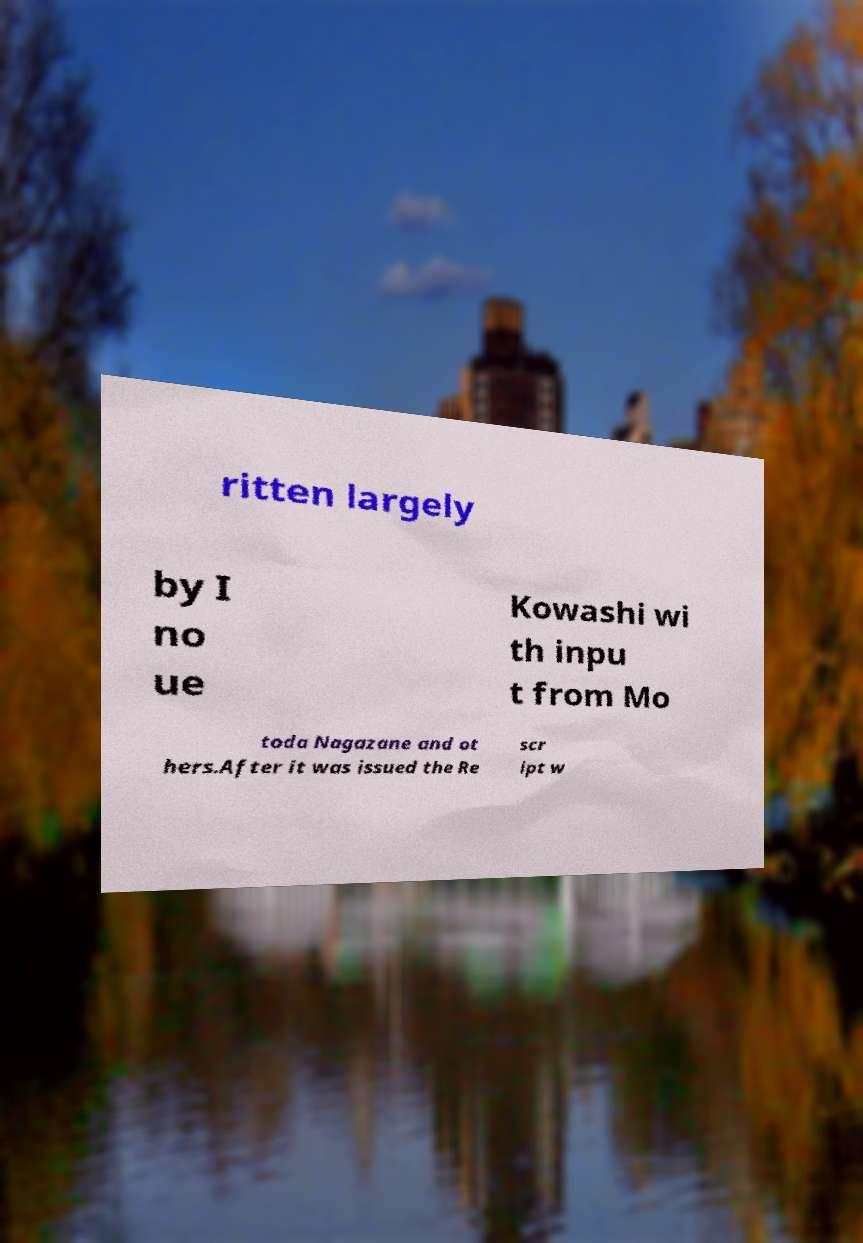Could you extract and type out the text from this image? ritten largely by I no ue Kowashi wi th inpu t from Mo toda Nagazane and ot hers.After it was issued the Re scr ipt w 